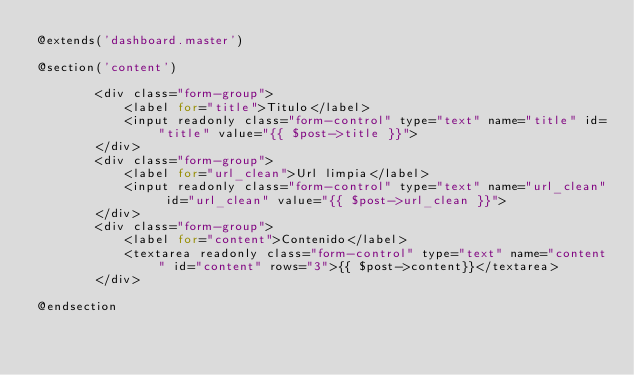Convert code to text. <code><loc_0><loc_0><loc_500><loc_500><_PHP_>@extends('dashboard.master')

@section('content')

        <div class="form-group">
            <label for="title">Titulo</label>
            <input readonly class="form-control" type="text" name="title" id="title" value="{{ $post->title }}">
        </div>
        <div class="form-group">
            <label for="url_clean">Url limpia</label>
            <input readonly class="form-control" type="text" name="url_clean" id="url_clean" value="{{ $post->url_clean }}">
        </div>
        <div class="form-group">
            <label for="content">Contenido</label>
            <textarea readonly class="form-control" type="text" name="content" id="content" rows="3">{{ $post->content}}</textarea>
        </div>

@endsection</code> 